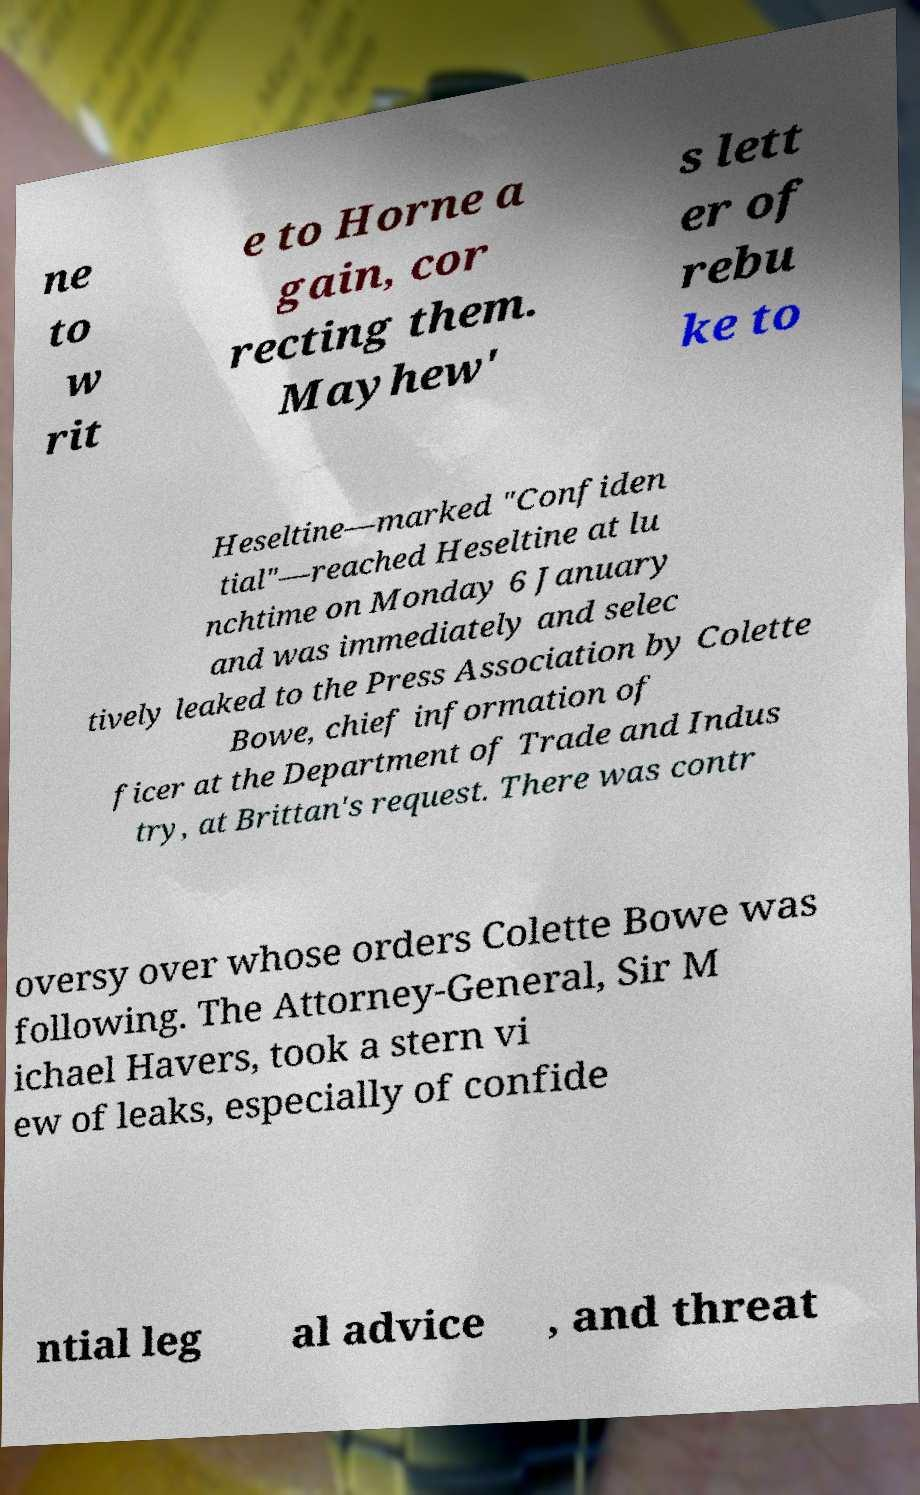Can you read and provide the text displayed in the image?This photo seems to have some interesting text. Can you extract and type it out for me? ne to w rit e to Horne a gain, cor recting them. Mayhew' s lett er of rebu ke to Heseltine—marked "Confiden tial"—reached Heseltine at lu nchtime on Monday 6 January and was immediately and selec tively leaked to the Press Association by Colette Bowe, chief information of ficer at the Department of Trade and Indus try, at Brittan's request. There was contr oversy over whose orders Colette Bowe was following. The Attorney-General, Sir M ichael Havers, took a stern vi ew of leaks, especially of confide ntial leg al advice , and threat 